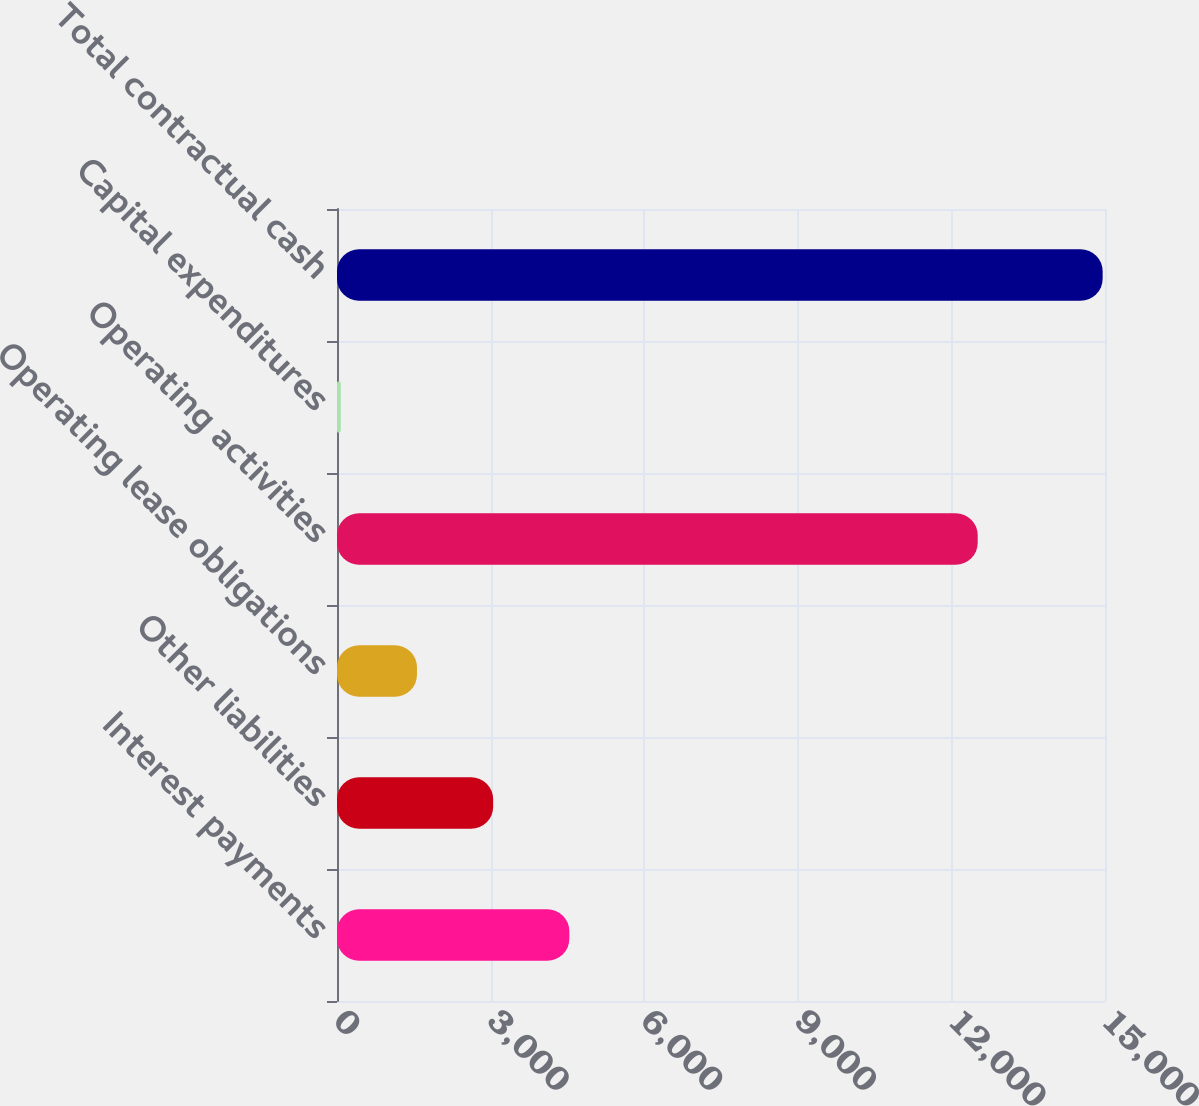Convert chart to OTSL. <chart><loc_0><loc_0><loc_500><loc_500><bar_chart><fcel>Interest payments<fcel>Other liabilities<fcel>Operating lease obligations<fcel>Operating activities<fcel>Capital expenditures<fcel>Total contractual cash<nl><fcel>4538<fcel>3050<fcel>1562<fcel>12514<fcel>74<fcel>14954<nl></chart> 